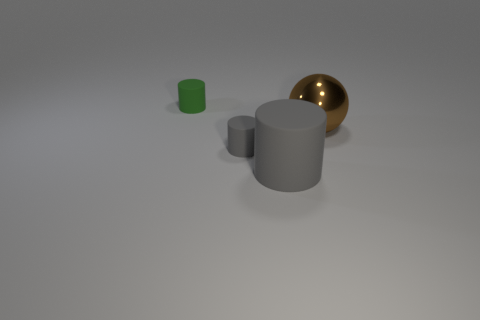Are there fewer small green matte things on the right side of the big gray matte cylinder than large gray matte cylinders that are behind the small green cylinder?
Your response must be concise. No. What is the brown ball made of?
Provide a short and direct response. Metal. Do the metal sphere and the small thing in front of the tiny green rubber cylinder have the same color?
Provide a succinct answer. No. There is a big brown metal object; what number of big brown metal things are right of it?
Provide a succinct answer. 0. Are there fewer small gray matte objects that are in front of the small gray matte thing than tiny green rubber cylinders?
Your answer should be very brief. Yes. The big cylinder is what color?
Offer a terse response. Gray. There is a small matte object behind the small gray matte cylinder; is it the same color as the metal sphere?
Your answer should be very brief. No. There is another large object that is the same shape as the green rubber object; what is its color?
Offer a terse response. Gray. What number of small things are purple matte spheres or gray matte objects?
Ensure brevity in your answer.  1. What size is the gray matte cylinder left of the large gray object?
Your answer should be very brief. Small. 